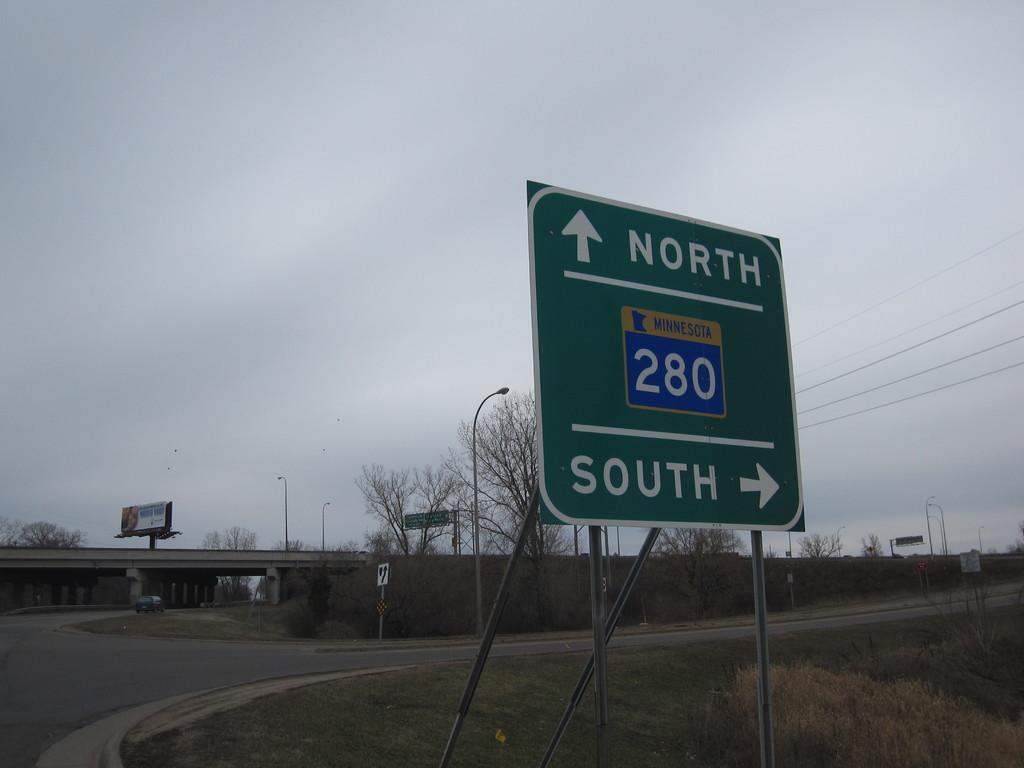Which way is south?
Your response must be concise. Right. 